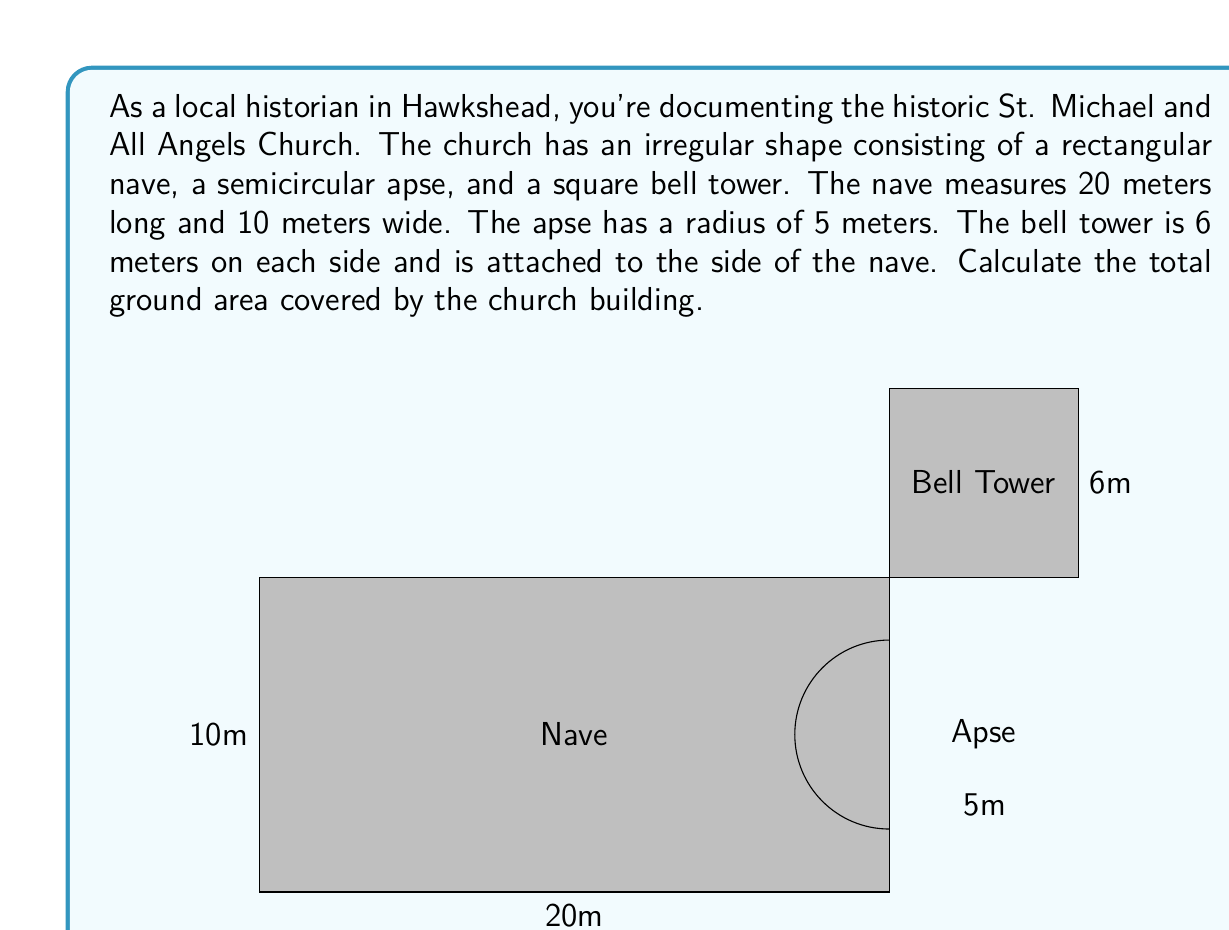Solve this math problem. To solve this problem, we need to calculate the areas of each part of the church and sum them up:

1. Area of the rectangular nave:
   $$A_{nave} = length \times width = 20 \text{ m} \times 10 \text{ m} = 200 \text{ m}^2$$

2. Area of the semicircular apse:
   The area of a full circle is $\pi r^2$, so for a semicircle, it's half of that.
   $$A_{apse} = \frac{1}{2} \pi r^2 = \frac{1}{2} \pi (5 \text{ m})^2 = \frac{25\pi}{2} \text{ m}^2$$

3. Area of the square bell tower:
   $$A_{tower} = side^2 = 6 \text{ m} \times 6 \text{ m} = 36 \text{ m}^2$$

Now, we sum up all these areas:

$$A_{total} = A_{nave} + A_{apse} + A_{tower}$$
$$A_{total} = 200 \text{ m}^2 + \frac{25\pi}{2} \text{ m}^2 + 36 \text{ m}^2$$
$$A_{total} = 236 + \frac{25\pi}{2} \text{ m}^2$$

To get a decimal approximation, we can use $\pi \approx 3.14159$:
$$A_{total} \approx 236 + \frac{25 \times 3.14159}{2} \text{ m}^2 \approx 275.27 \text{ m}^2$$
Answer: The total ground area covered by St. Michael and All Angels Church is $236 + \frac{25\pi}{2} \text{ m}^2$ or approximately 275.27 m². 